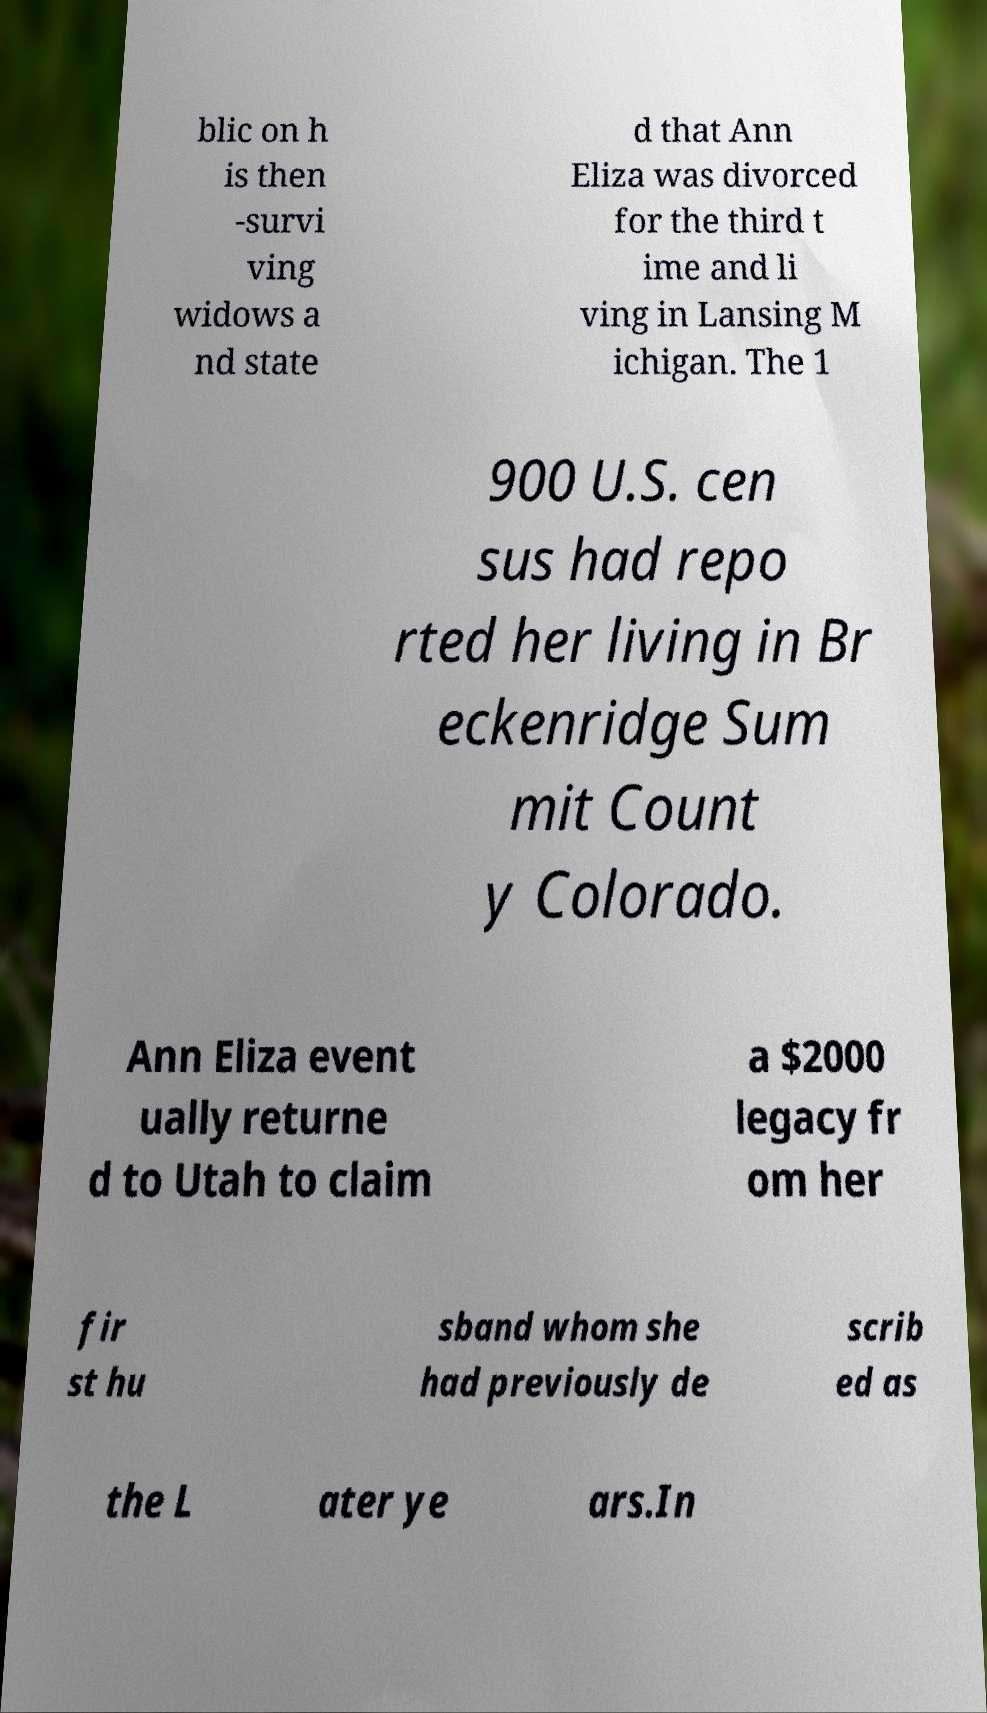Please read and relay the text visible in this image. What does it say? blic on h is then -survi ving widows a nd state d that Ann Eliza was divorced for the third t ime and li ving in Lansing M ichigan. The 1 900 U.S. cen sus had repo rted her living in Br eckenridge Sum mit Count y Colorado. Ann Eliza event ually returne d to Utah to claim a $2000 legacy fr om her fir st hu sband whom she had previously de scrib ed as the L ater ye ars.In 